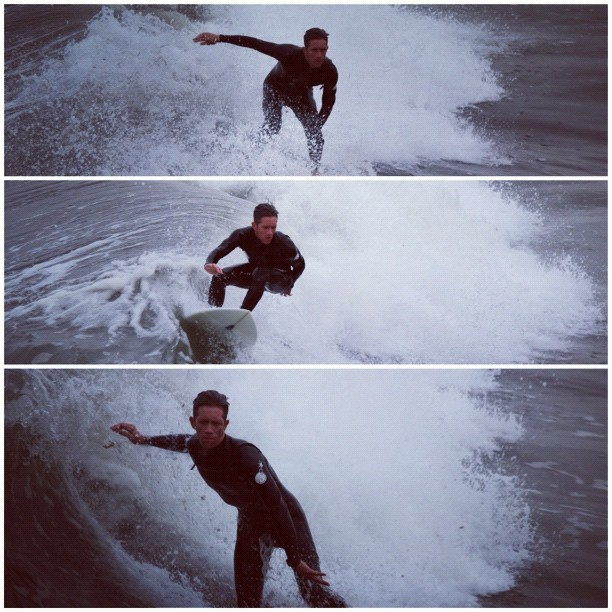Describe the objects in this image and their specific colors. I can see people in ivory, black, maroon, gray, and purple tones, people in ivory, black, gray, maroon, and darkgray tones, people in ivory, black, gray, maroon, and purple tones, surfboard in ivory, gray, and darkgray tones, and surfboard in ivory, darkgray, and lavender tones in this image. 